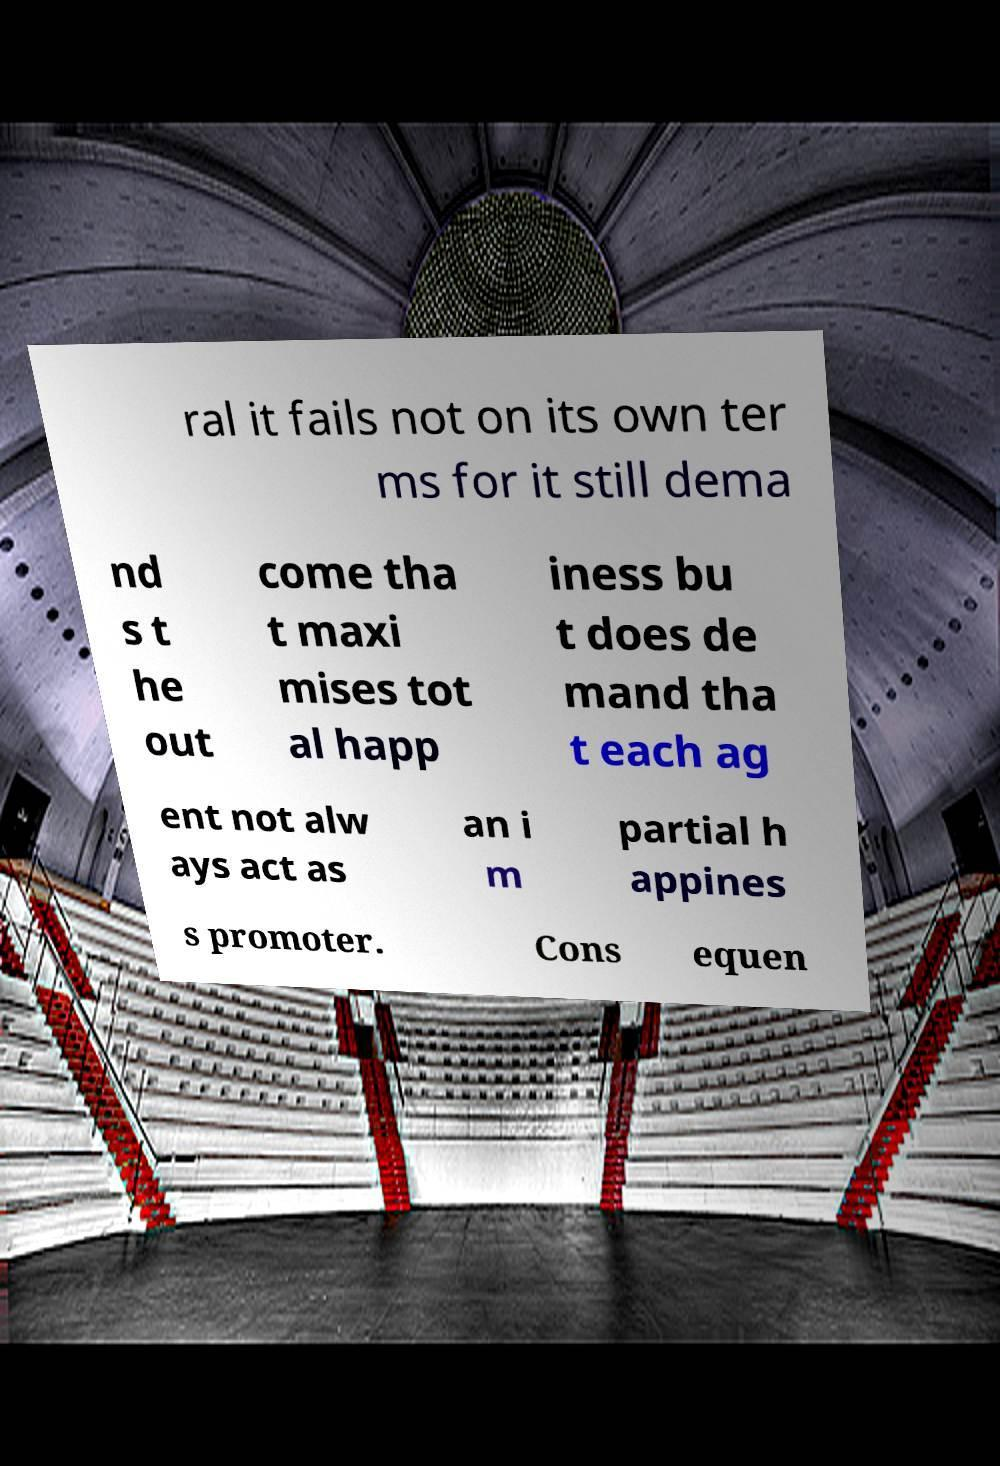Could you assist in decoding the text presented in this image and type it out clearly? ral it fails not on its own ter ms for it still dema nd s t he out come tha t maxi mises tot al happ iness bu t does de mand tha t each ag ent not alw ays act as an i m partial h appines s promoter. Cons equen 